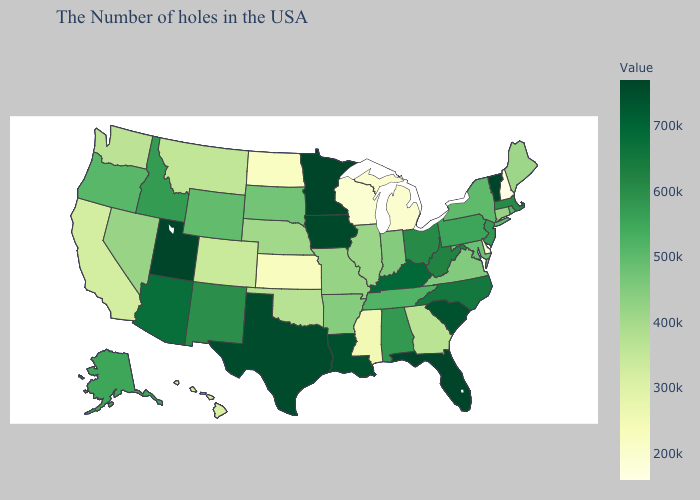Does Oregon have a lower value than Delaware?
Keep it brief. No. Does New York have a lower value than Mississippi?
Keep it brief. No. Does Mississippi have the lowest value in the South?
Short answer required. No. Does the map have missing data?
Give a very brief answer. No. Among the states that border Michigan , which have the lowest value?
Write a very short answer. Wisconsin. Does Mississippi have a lower value than New Hampshire?
Short answer required. No. Does New Hampshire have the lowest value in the USA?
Write a very short answer. Yes. 